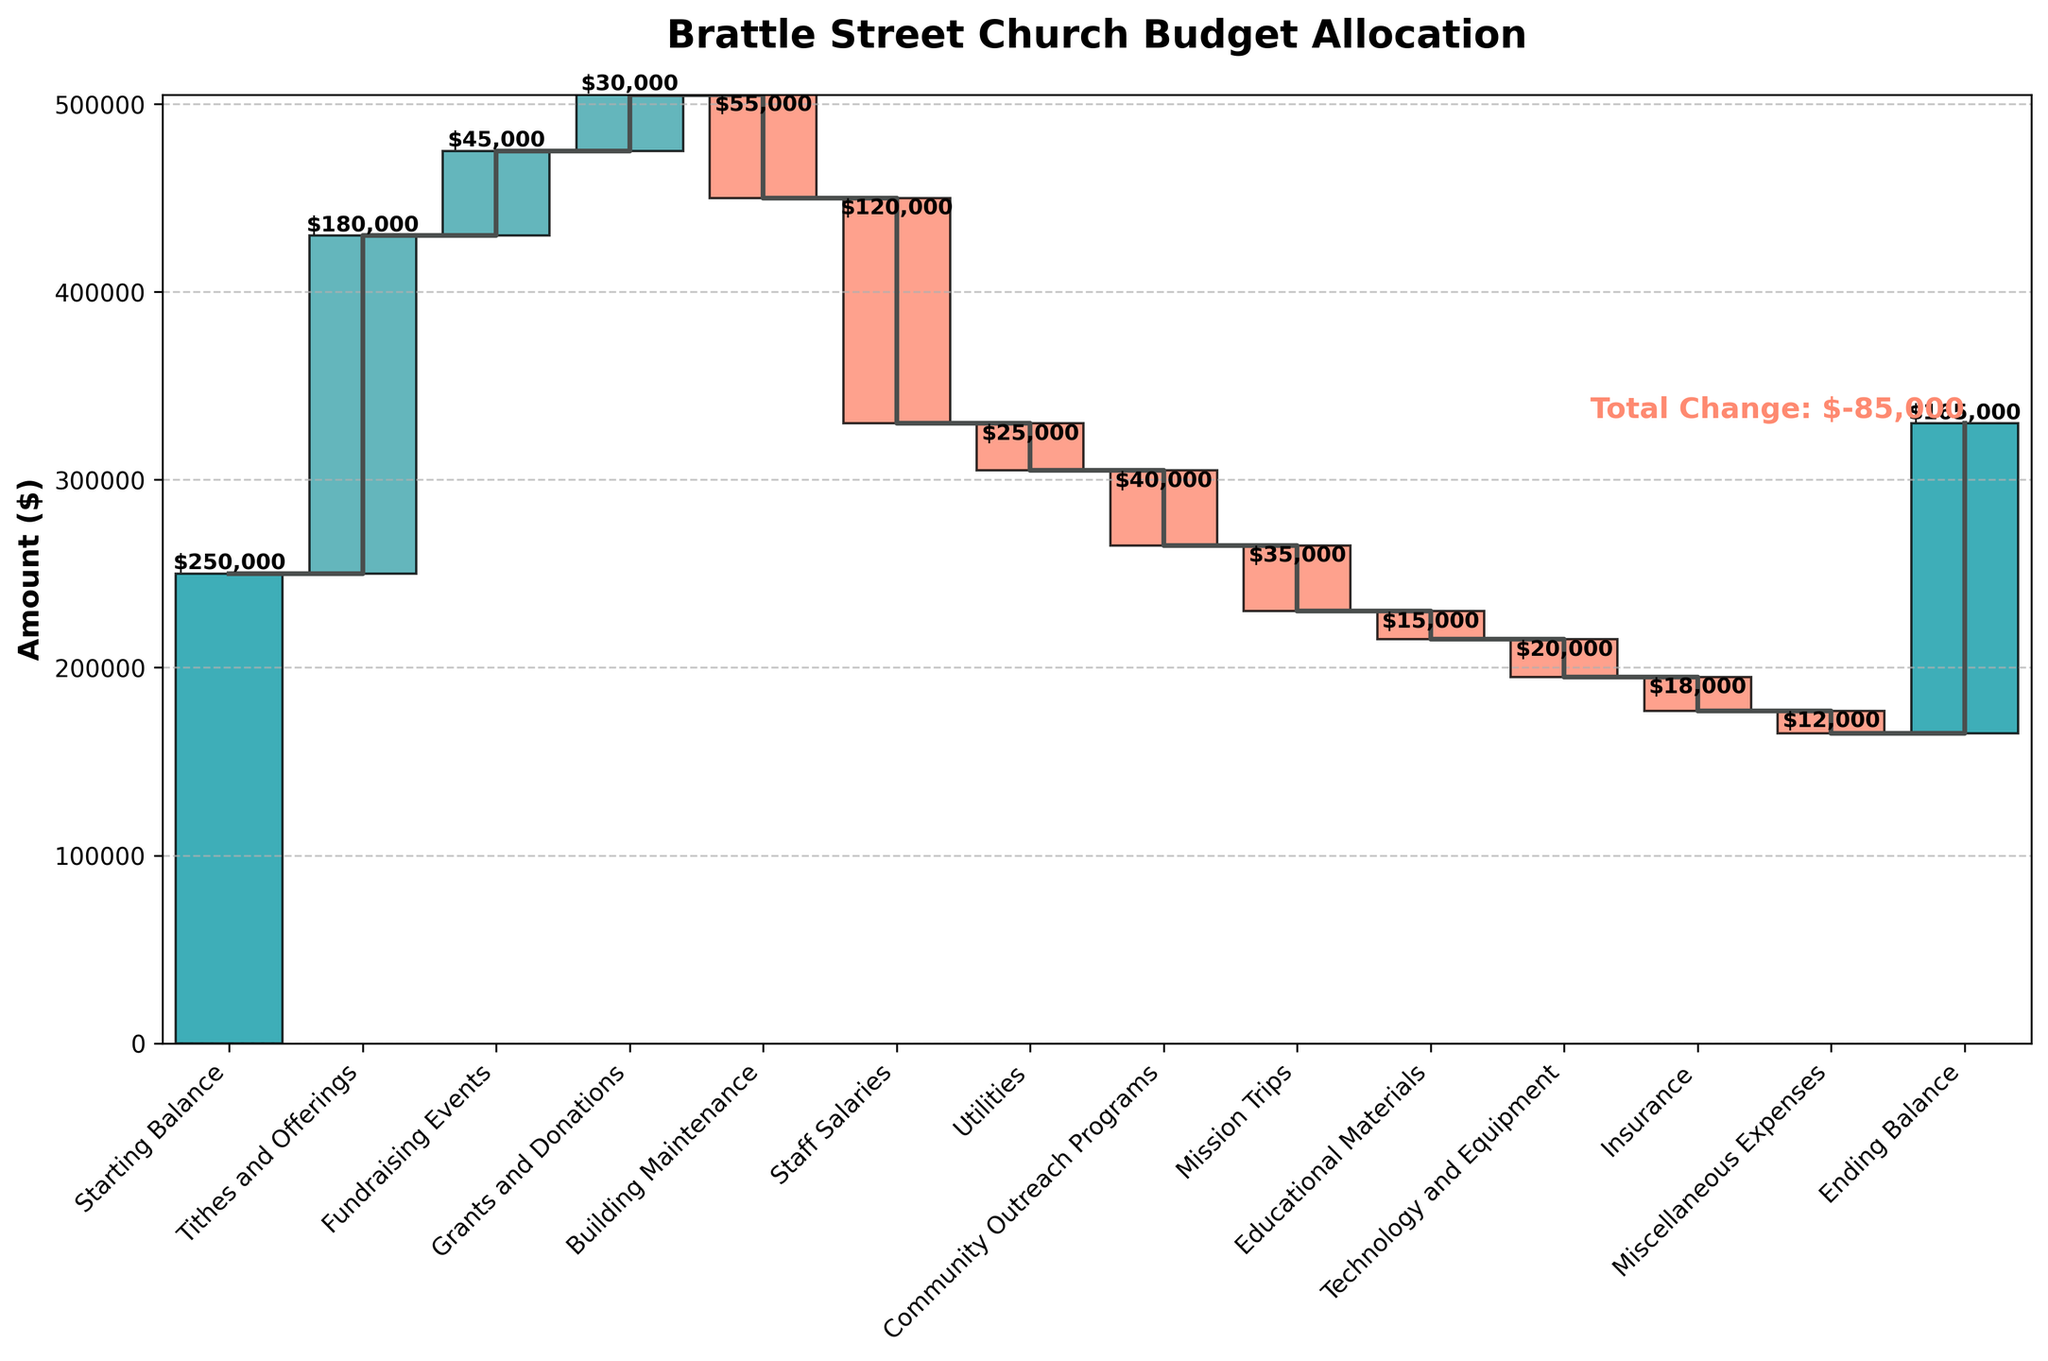What is the title of the waterfall chart? The title of the chart is prominently displayed at the top and is usually the largest text on the figure.
Answer: Brattle Street Church Budget Allocation How many categories are listed on the x-axis? Count the number of labels on the x-axis to determine the number of categories.
Answer: 13 Which category has the largest positive amount? Identify the category with the largest upward bar or step, which indicates the highest positive amount added to the budget.
Answer: Tithes and Offerings What is the total amount deducted for staff salaries? Find the bar or step labeled "Staff Salaries" and note the amount displayed on it. This category has a negative value.
Answer: $120,000 What is the ending balance of the budget? Look at the final category labeled "Ending Balance" to see the cumulative total at the end of the chart.
Answer: $165,000 How much more was spent on building maintenance compared to educational materials? Locate the amounts for "Building Maintenance" and "Educational Materials" and calculate the difference: $55,000 (Building Maintenance) - $15,000 (Educational Materials).
Answer: $40,000 Compare the amounts received from fundraising events and grants and donations. Which is higher and by how much? Review the values for "Fundraising Events" and "Grants and Donations," then subtract the smaller amount from the larger: $45,000 (Fundraising Events) - $30,000 (Grants and Donations).
Answer: Fundraising Events by $15,000 What is the cumulative budget after utilities are deducted? Calculate the cumulative sum up to and including the "Utilities" category. Starting Balance $250,000 + Tithes and Offerings $180,000 + Fundraising Events $45,000 + Grants and Donations $30,000 - Building Maintenance $55,000 - Staff Salaries $120,000 - Utilities $25,000.
Answer: $305,000 How does the amount spent on mission trips compare to technology and equipment? Identify the amounts for "Mission Trips" and "Technology and Equipment" and state the difference: $35,000 (Mission Trips) - $20,000 (Technology and Equipment).
Answer: Mission Trips by $15,000 What is the total amount of miscellaneous expenses? Look for the category labeled "Miscellaneous Expenses" to find the specific amount associated with it.
Answer: $12,000 